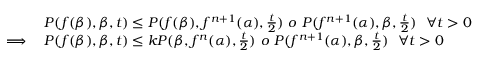<formula> <loc_0><loc_0><loc_500><loc_500>\begin{array} { r l } & { P ( f ( \beta ) , \beta , t ) \leq P ( f ( \beta ) , f ^ { n + 1 } ( \alpha ) , \frac { t } { 2 } ) o P ( f ^ { n + 1 } ( \alpha ) , \beta , \frac { t } { 2 } ) \forall t > 0 } \\ { \implies } & { P ( f ( \beta ) , \beta , t ) \leq k P ( \beta , f ^ { n } ( \alpha ) , \frac { t } { 2 } ) o P ( f ^ { n + 1 } ( \alpha ) , \beta , \frac { t } { 2 } ) \forall t > 0 } \end{array}</formula> 